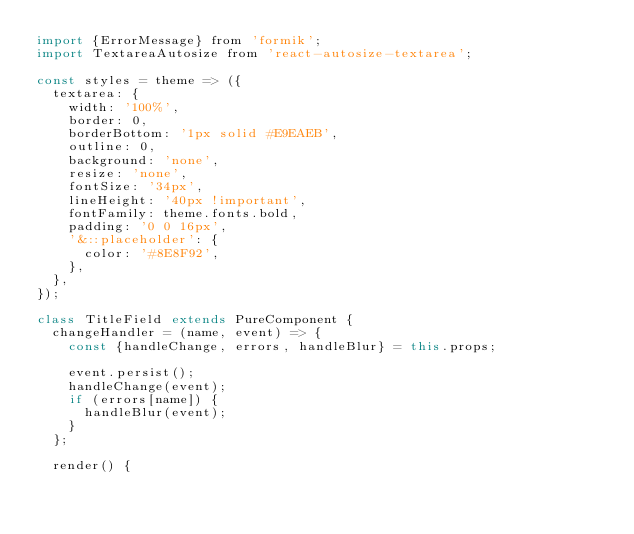Convert code to text. <code><loc_0><loc_0><loc_500><loc_500><_JavaScript_>import {ErrorMessage} from 'formik';
import TextareaAutosize from 'react-autosize-textarea';

const styles = theme => ({
  textarea: {
    width: '100%',
    border: 0,
    borderBottom: '1px solid #E9EAEB',
    outline: 0,
    background: 'none',
    resize: 'none',
    fontSize: '34px',
    lineHeight: '40px !important',
    fontFamily: theme.fonts.bold,
    padding: '0 0 16px',
    '&::placeholder': {
      color: '#8E8F92',
    },
  },
});

class TitleField extends PureComponent {
  changeHandler = (name, event) => {
    const {handleChange, errors, handleBlur} = this.props;

    event.persist();
    handleChange(event);
    if (errors[name]) {
      handleBlur(event);
    }
  };

  render() {</code> 